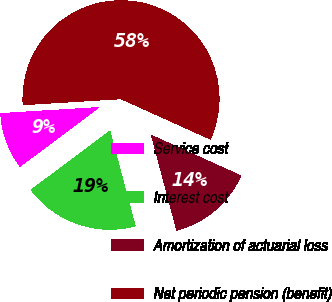Convert chart to OTSL. <chart><loc_0><loc_0><loc_500><loc_500><pie_chart><fcel>Service cost<fcel>Interest cost<fcel>Amortization of actuarial loss<fcel>Net periodic pension (benefit)<nl><fcel>9.24%<fcel>18.94%<fcel>14.09%<fcel>57.74%<nl></chart> 